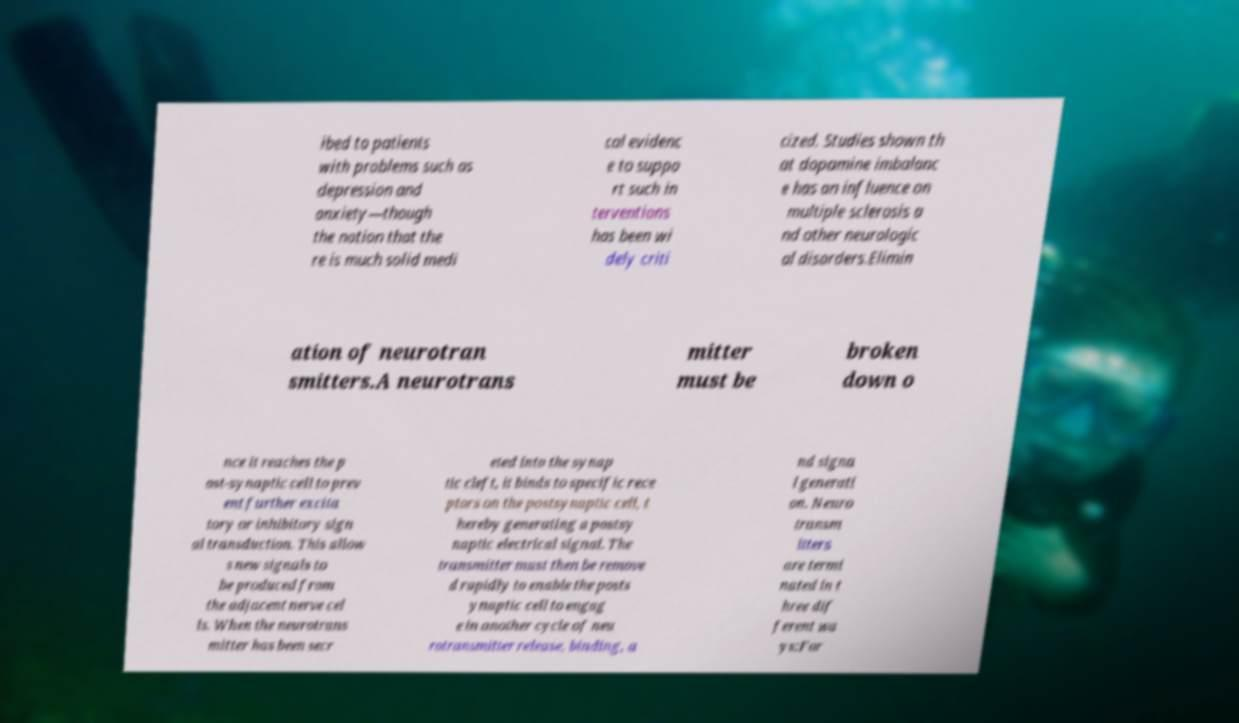Please identify and transcribe the text found in this image. ibed to patients with problems such as depression and anxiety—though the notion that the re is much solid medi cal evidenc e to suppo rt such in terventions has been wi dely criti cized. Studies shown th at dopamine imbalanc e has an influence on multiple sclerosis a nd other neurologic al disorders.Elimin ation of neurotran smitters.A neurotrans mitter must be broken down o nce it reaches the p ost-synaptic cell to prev ent further excita tory or inhibitory sign al transduction. This allow s new signals to be produced from the adjacent nerve cel ls. When the neurotrans mitter has been secr eted into the synap tic cleft, it binds to specific rece ptors on the postsynaptic cell, t hereby generating a postsy naptic electrical signal. The transmitter must then be remove d rapidly to enable the posts ynaptic cell to engag e in another cycle of neu rotransmitter release, binding, a nd signa l generati on. Neuro transm itters are termi nated in t hree dif ferent wa ys:For 